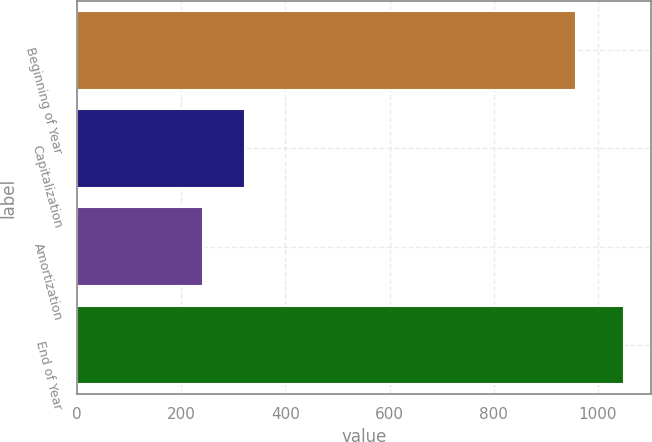Convert chart. <chart><loc_0><loc_0><loc_500><loc_500><bar_chart><fcel>Beginning of Year<fcel>Capitalization<fcel>Amortization<fcel>End of Year<nl><fcel>957.9<fcel>322.98<fcel>242.2<fcel>1050<nl></chart> 